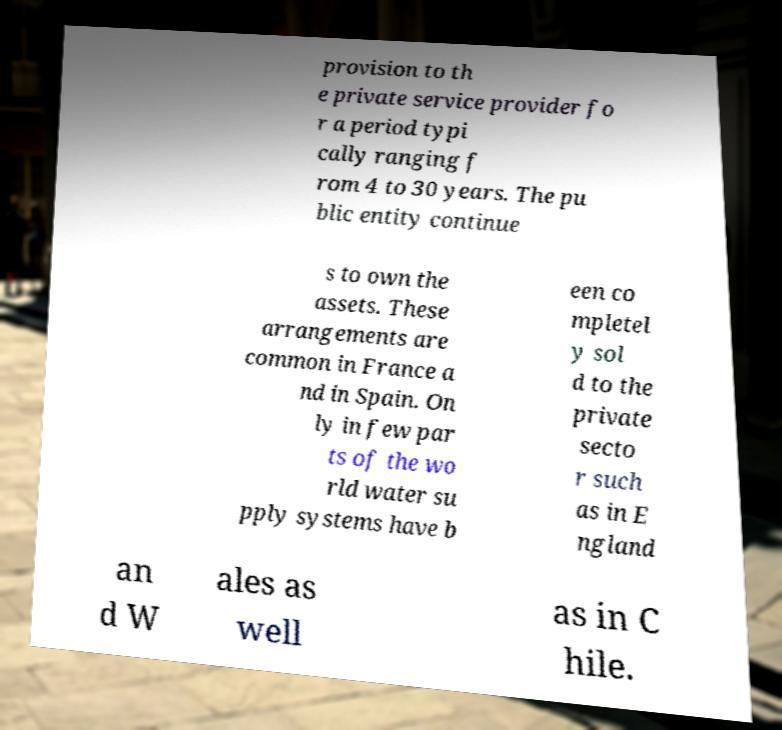Could you assist in decoding the text presented in this image and type it out clearly? provision to th e private service provider fo r a period typi cally ranging f rom 4 to 30 years. The pu blic entity continue s to own the assets. These arrangements are common in France a nd in Spain. On ly in few par ts of the wo rld water su pply systems have b een co mpletel y sol d to the private secto r such as in E ngland an d W ales as well as in C hile. 